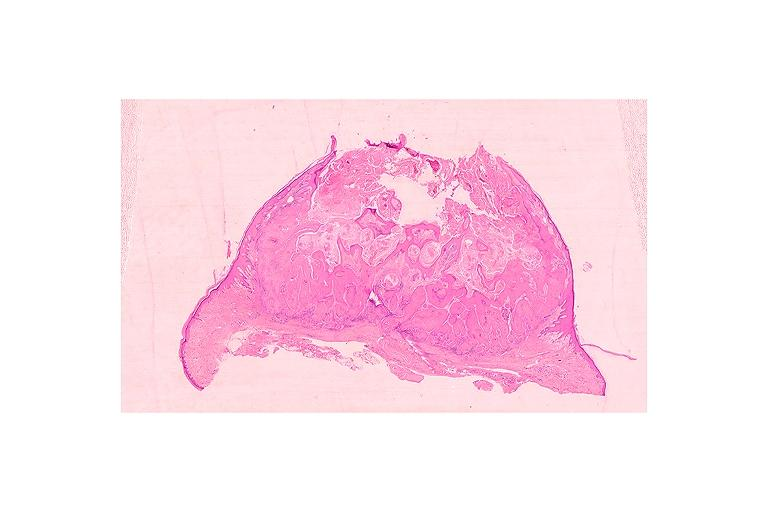what does this image show?
Answer the question using a single word or phrase. Keratoacanthoma 